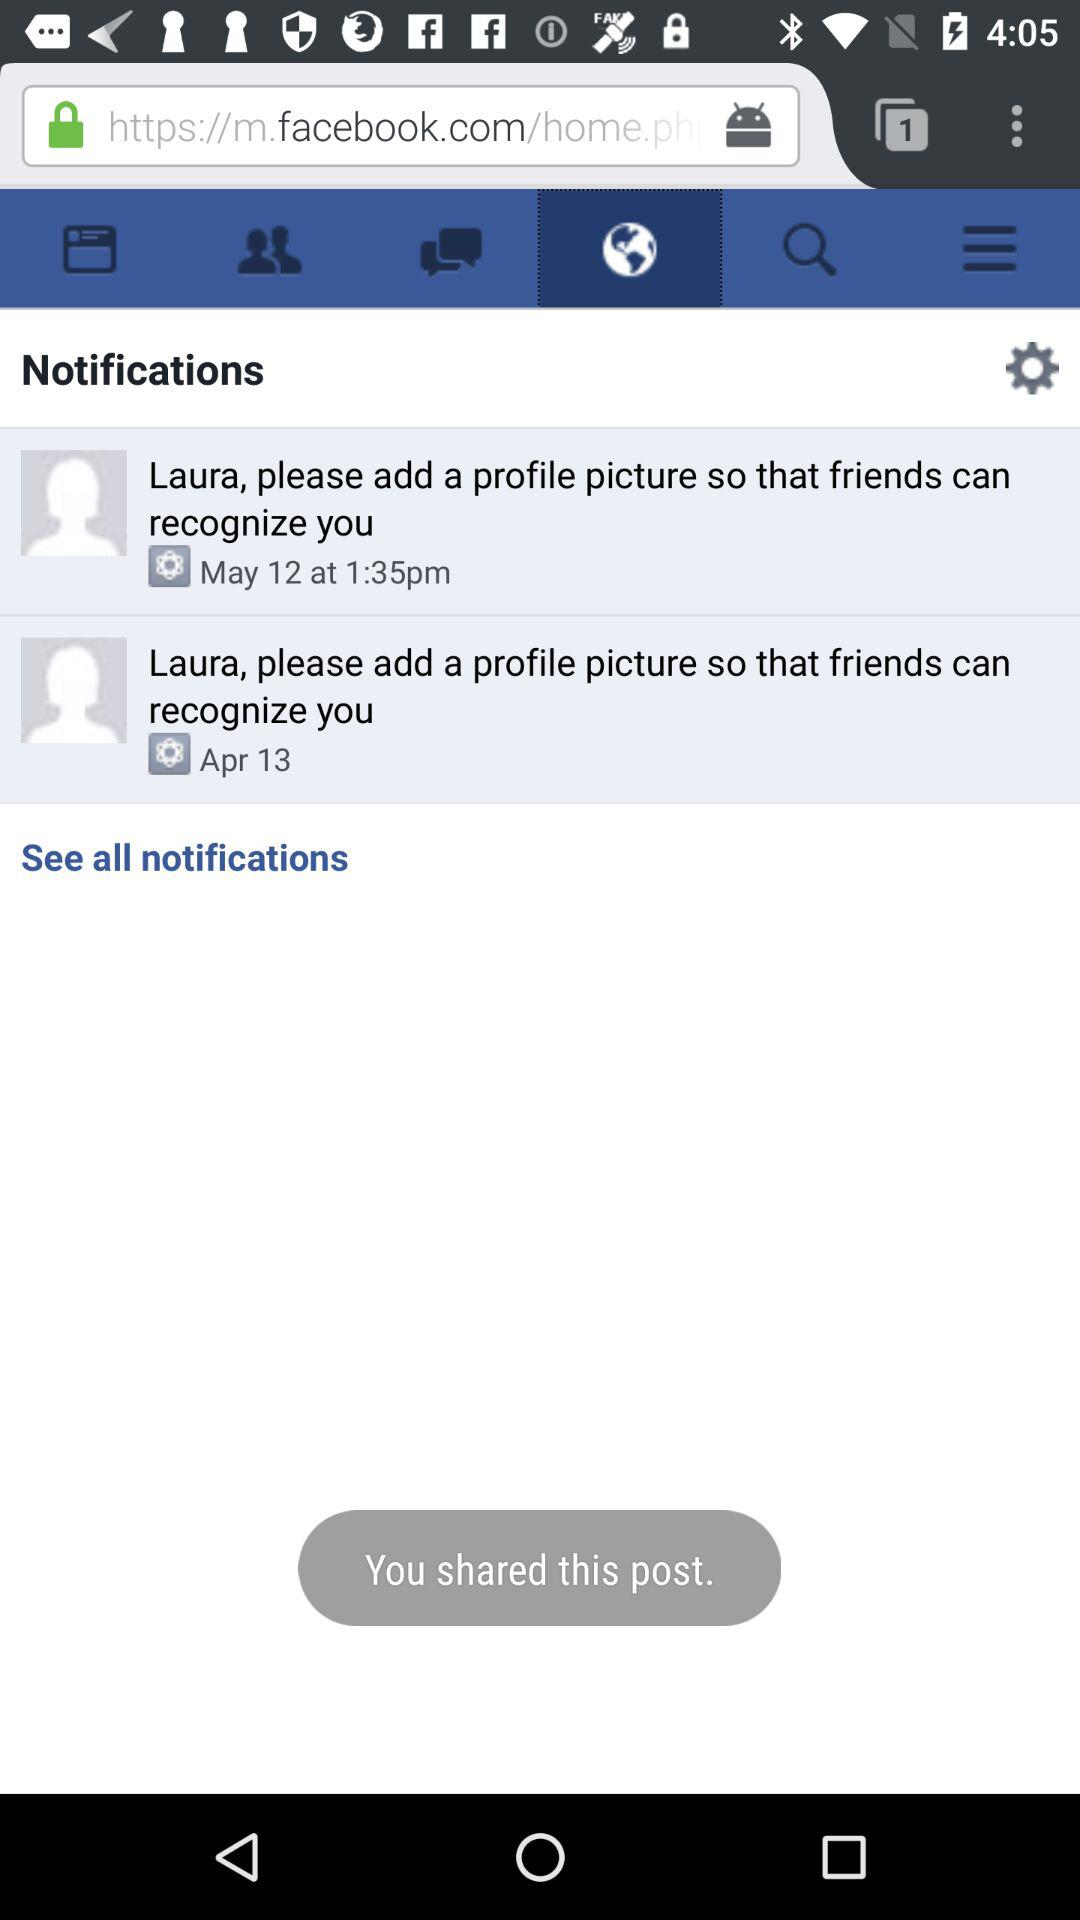How many notifications are there?
Answer the question using a single word or phrase. 2 